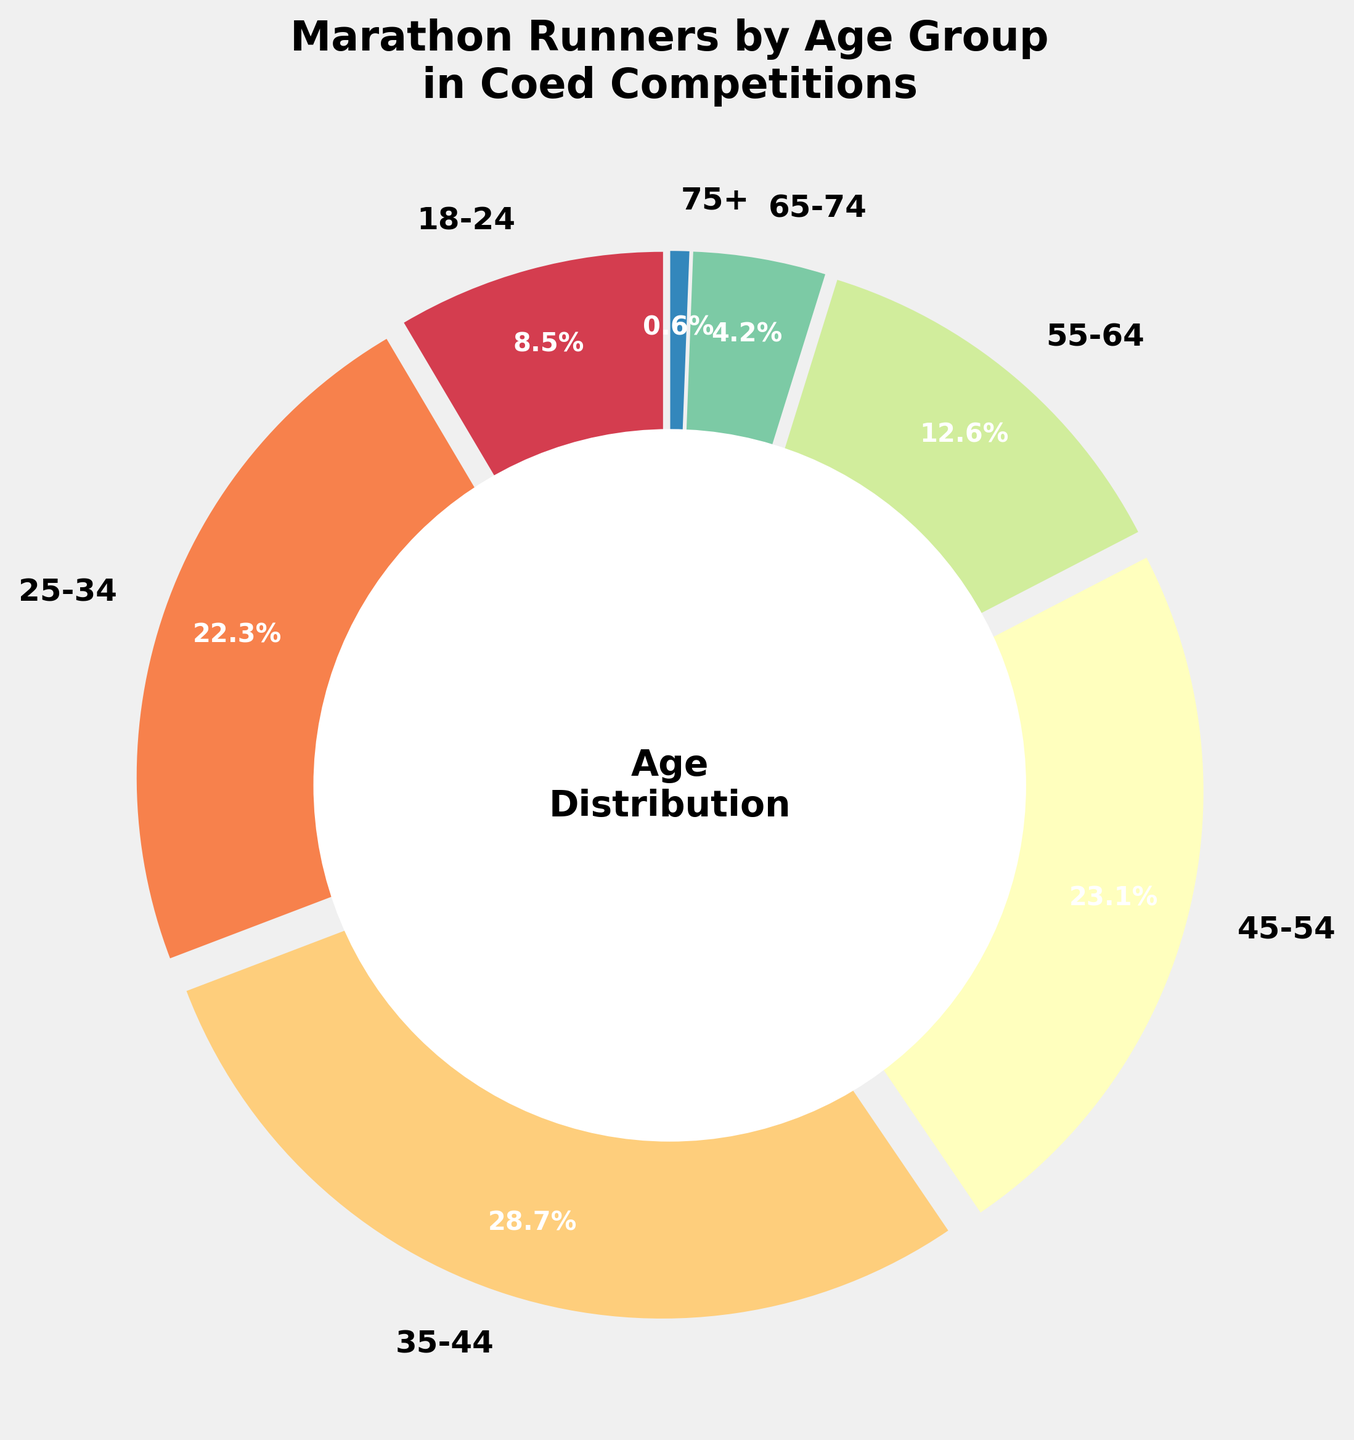What age group has the highest percentage of marathon runners? Look at the slices and percentages in the pie chart. The 35-44 age group has the largest slice and percentage of 28.7%.
Answer: 35-44 Which age group has a greater percentage of marathon runners, 18-24 or 45-54? Compare the two percentages. The 45-54 age group has 23.1%, which is greater than the 18-24 age group's 8.5%.
Answer: 45-54 What is the difference in percentage between the 25-34 and 55-64 age groups? Subtract the percentage of the 55-64 age group (12.6%) from the percentage of the 25-34 age group (22.3%).
Answer: 9.7% How many age groups have a percentage higher than 20%? Identify the age groups with percentages greater than 20%. They are 25-34, 35-44, and 45-54.
Answer: 3 What is the total percentage of marathon runners aged 45-74? Sum the percentages of the 45-54 (23.1%), 55-64 (12.6%), and 65-74 (4.2%) age groups.
Answer: 39.9% Is the percentage of marathon runners aged 18-24 greater than the total percentage of those aged 65 and over? Compare the percentages. The 18-24 age group has 8.5%, which is greater than the combined percentage of 65-74 (4.2%) and 75+ (0.6%), totaling 4.8%.
Answer: Yes Which age groups together make up more than half of the total marathon runners? Identify and sum percentages until surpassing 50%. The 35-44 (28.7%) and 45-54 (23.1%) together make up 51.8%.
Answer: 35-44 and 45-54 Which age group has the least representation in marathon runners? Look for the smallest percentage. The 75+ age group has the smallest percentage of 0.6%.
Answer: 75+ Which two age groups have the closest percentages of marathon runners? Compare adjoining percentages. The 18-24 (8.5%) and 65-74 (4.2%) are closest, but the closest pair is 55-64 (12.6%) and 18-24 (8.5%) with a difference of 4.1%.
Answer: 55-64 and 18-24 